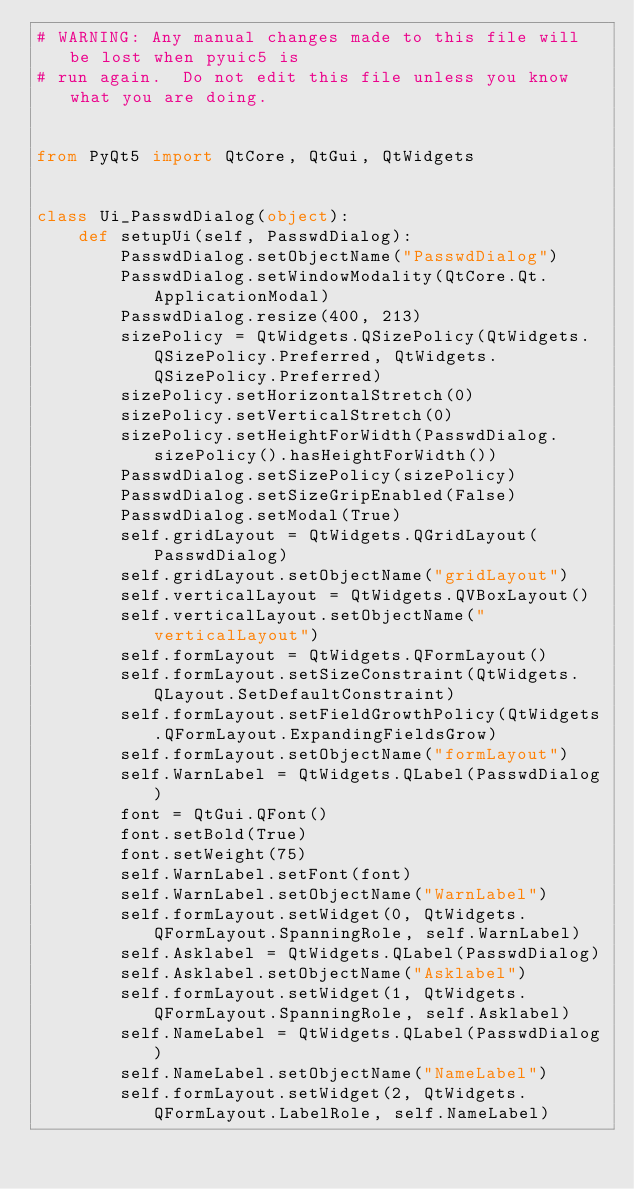Convert code to text. <code><loc_0><loc_0><loc_500><loc_500><_Python_># WARNING: Any manual changes made to this file will be lost when pyuic5 is
# run again.  Do not edit this file unless you know what you are doing.


from PyQt5 import QtCore, QtGui, QtWidgets


class Ui_PasswdDialog(object):
    def setupUi(self, PasswdDialog):
        PasswdDialog.setObjectName("PasswdDialog")
        PasswdDialog.setWindowModality(QtCore.Qt.ApplicationModal)
        PasswdDialog.resize(400, 213)
        sizePolicy = QtWidgets.QSizePolicy(QtWidgets.QSizePolicy.Preferred, QtWidgets.QSizePolicy.Preferred)
        sizePolicy.setHorizontalStretch(0)
        sizePolicy.setVerticalStretch(0)
        sizePolicy.setHeightForWidth(PasswdDialog.sizePolicy().hasHeightForWidth())
        PasswdDialog.setSizePolicy(sizePolicy)
        PasswdDialog.setSizeGripEnabled(False)
        PasswdDialog.setModal(True)
        self.gridLayout = QtWidgets.QGridLayout(PasswdDialog)
        self.gridLayout.setObjectName("gridLayout")
        self.verticalLayout = QtWidgets.QVBoxLayout()
        self.verticalLayout.setObjectName("verticalLayout")
        self.formLayout = QtWidgets.QFormLayout()
        self.formLayout.setSizeConstraint(QtWidgets.QLayout.SetDefaultConstraint)
        self.formLayout.setFieldGrowthPolicy(QtWidgets.QFormLayout.ExpandingFieldsGrow)
        self.formLayout.setObjectName("formLayout")
        self.WarnLabel = QtWidgets.QLabel(PasswdDialog)
        font = QtGui.QFont()
        font.setBold(True)
        font.setWeight(75)
        self.WarnLabel.setFont(font)
        self.WarnLabel.setObjectName("WarnLabel")
        self.formLayout.setWidget(0, QtWidgets.QFormLayout.SpanningRole, self.WarnLabel)
        self.Asklabel = QtWidgets.QLabel(PasswdDialog)
        self.Asklabel.setObjectName("Asklabel")
        self.formLayout.setWidget(1, QtWidgets.QFormLayout.SpanningRole, self.Asklabel)
        self.NameLabel = QtWidgets.QLabel(PasswdDialog)
        self.NameLabel.setObjectName("NameLabel")
        self.formLayout.setWidget(2, QtWidgets.QFormLayout.LabelRole, self.NameLabel)</code> 